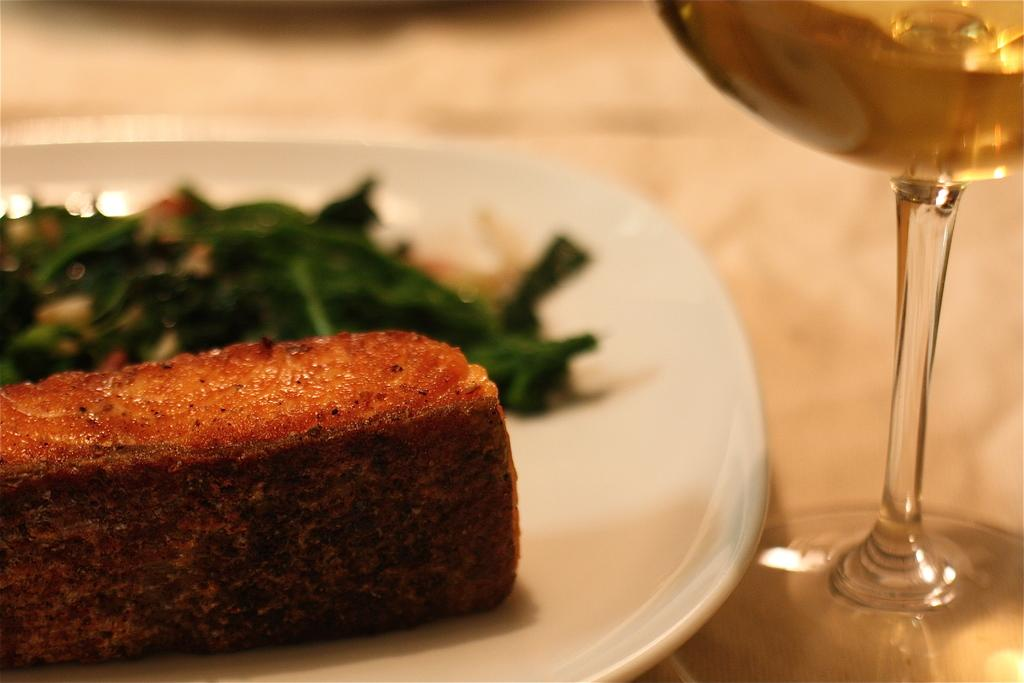What is on the white plate in the image? There are food items on a white plate in the image. What can be seen in the glass in the image? There is a glass with a drink in the image. Where is the glass with a drink located? The glass with a drink is on a surface in the image. Can you describe any visual quality of the image? The image has a slightly blurred area. What time of day does the ghost appear in the image? There is no ghost present in the image, so it is not possible to determine when a ghost might appear. 